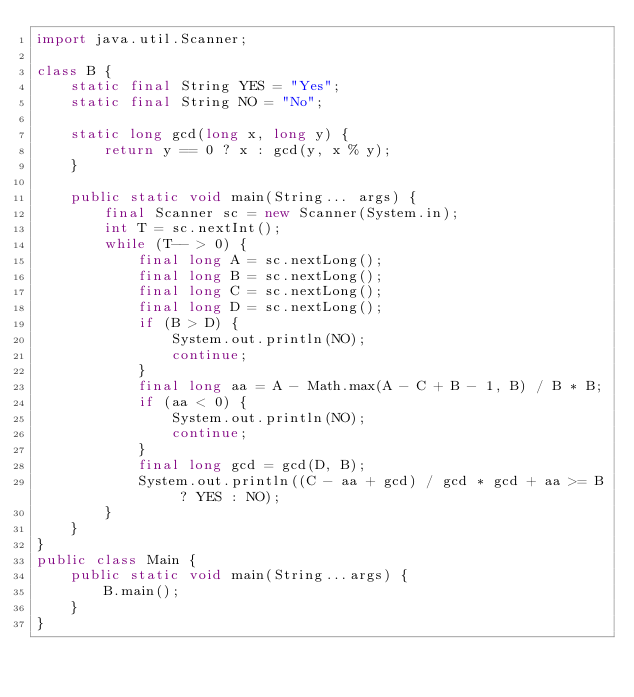Convert code to text. <code><loc_0><loc_0><loc_500><loc_500><_Java_>import java.util.Scanner;

class B {
    static final String YES = "Yes";
    static final String NO = "No";

    static long gcd(long x, long y) {
        return y == 0 ? x : gcd(y, x % y);
    }

    public static void main(String... args) {
        final Scanner sc = new Scanner(System.in);
        int T = sc.nextInt();
        while (T-- > 0) {
            final long A = sc.nextLong();
            final long B = sc.nextLong();
            final long C = sc.nextLong();
            final long D = sc.nextLong();
            if (B > D) {
                System.out.println(NO);
                continue;
            }
            final long aa = A - Math.max(A - C + B - 1, B) / B * B;
            if (aa < 0) {
                System.out.println(NO);
                continue;
            }
            final long gcd = gcd(D, B);
            System.out.println((C - aa + gcd) / gcd * gcd + aa >= B ? YES : NO);
        }
    }
}
public class Main {
    public static void main(String...args) {
        B.main();
    }
}
</code> 